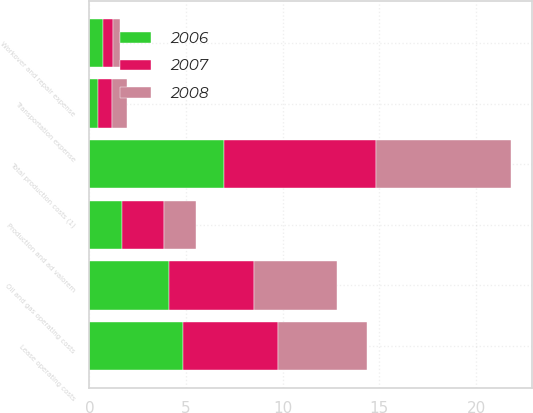<chart> <loc_0><loc_0><loc_500><loc_500><stacked_bar_chart><ecel><fcel>Oil and gas operating costs<fcel>Workover and repair expense<fcel>Lease operating costs<fcel>Production and ad valorem<fcel>Transportation expense<fcel>Total production costs (1)<nl><fcel>2007<fcel>4.39<fcel>0.51<fcel>4.9<fcel>2.19<fcel>0.75<fcel>7.84<nl><fcel>2008<fcel>4.29<fcel>0.33<fcel>4.62<fcel>1.63<fcel>0.74<fcel>6.99<nl><fcel>2006<fcel>4.14<fcel>0.72<fcel>4.86<fcel>1.67<fcel>0.44<fcel>6.97<nl></chart> 